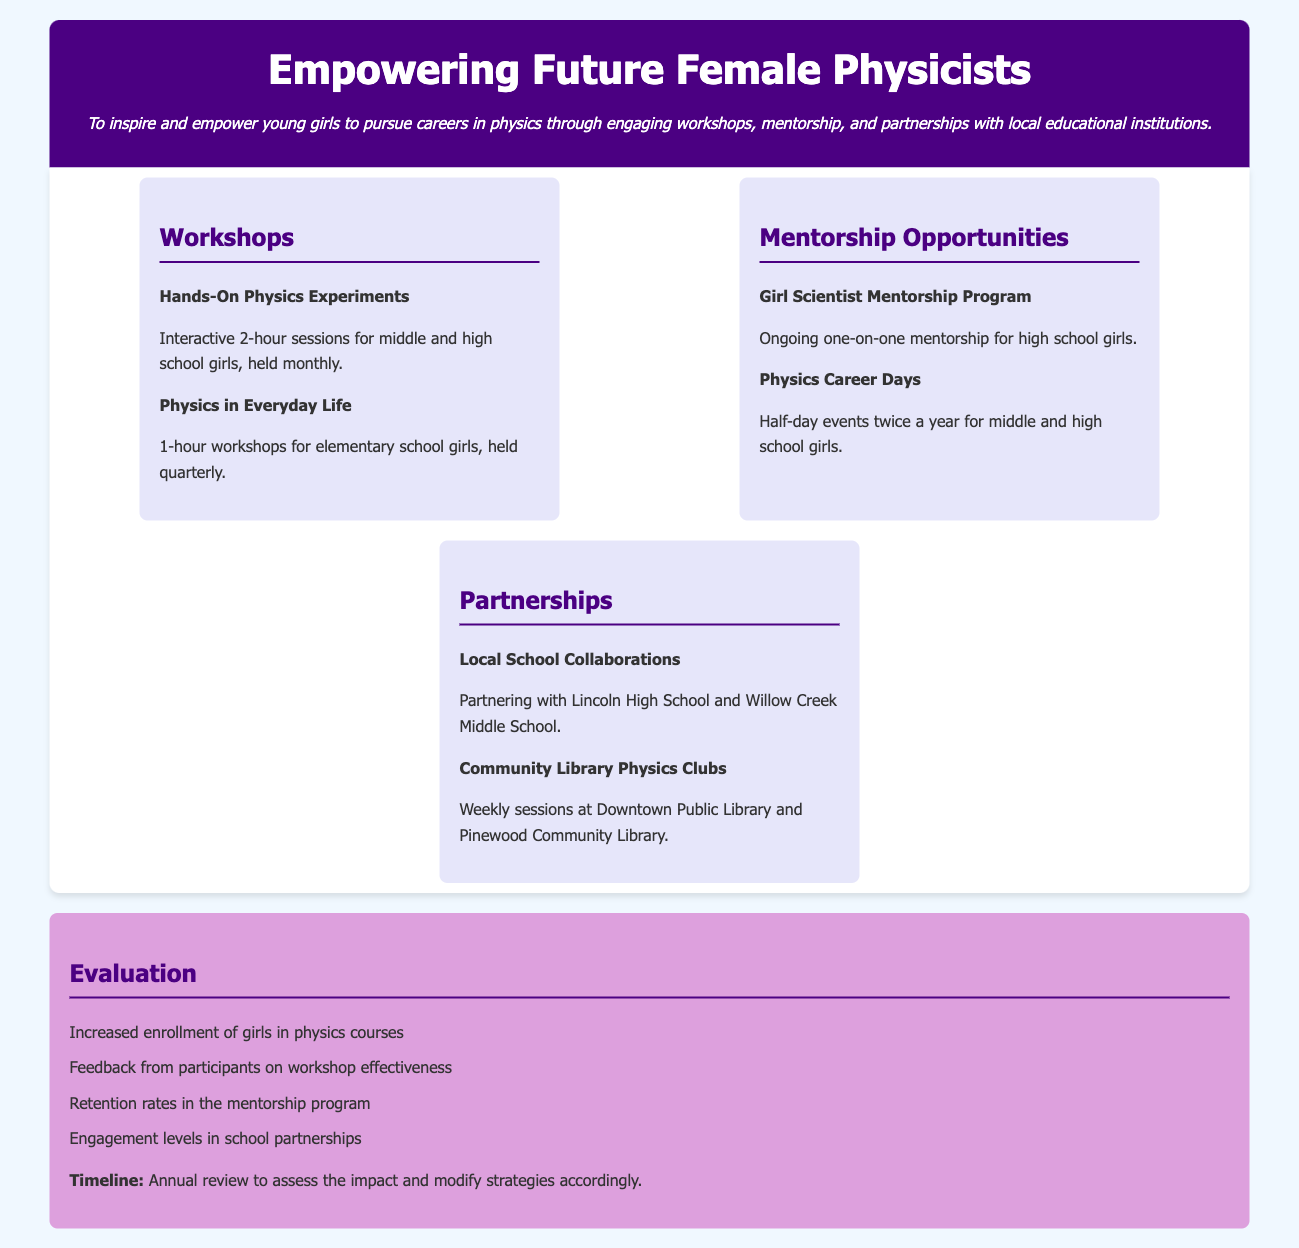How often are the Hands-On Physics Experiments held? The document states that the Hands-On Physics Experiments are held monthly for middle and high school girls.
Answer: monthly What organizations are collaborating with local schools? The document lists Lincoln High School and Willow Creek Middle School as the local school collaborations.
Answer: Lincoln High School and Willow Creek Middle School How many Physics Career Days are held each year? The document mentions that Physics Career Days are held twice a year for middle and high school girls.
Answer: twice a year What is the main purpose of the community outreach program? The mission statement in the document highlights that the main purpose is to inspire and empower young girls to pursue careers in physics.
Answer: inspire and empower young girls What type of workshops are conducted for elementary school girls? The document specifies that 1-hour workshops for elementary school girls are titled "Physics in Everyday Life."
Answer: Physics in Everyday Life What is evaluated in the program? The document lists several criteria including increased enrollment of girls in physics courses and feedback from participants on workshop effectiveness.
Answer: increased enrollment of girls in physics courses How many hands-on sessions are planned monthly? The document details that each interactive session lasts 2 hours, but does not specify the total number; it describes ongoing monthly sessions.
Answer: ongoing monthly sessions 